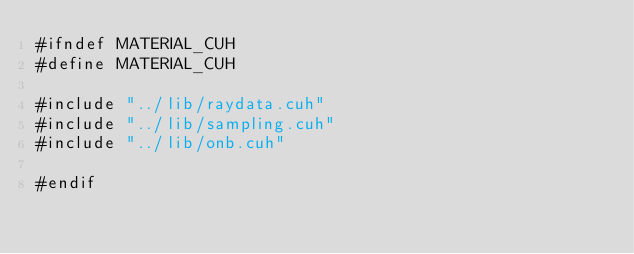Convert code to text. <code><loc_0><loc_0><loc_500><loc_500><_Cuda_>#ifndef MATERIAL_CUH
#define MATERIAL_CUH

#include "../lib/raydata.cuh"
#include "../lib/sampling.cuh"
#include "../lib/onb.cuh"

#endif
</code> 